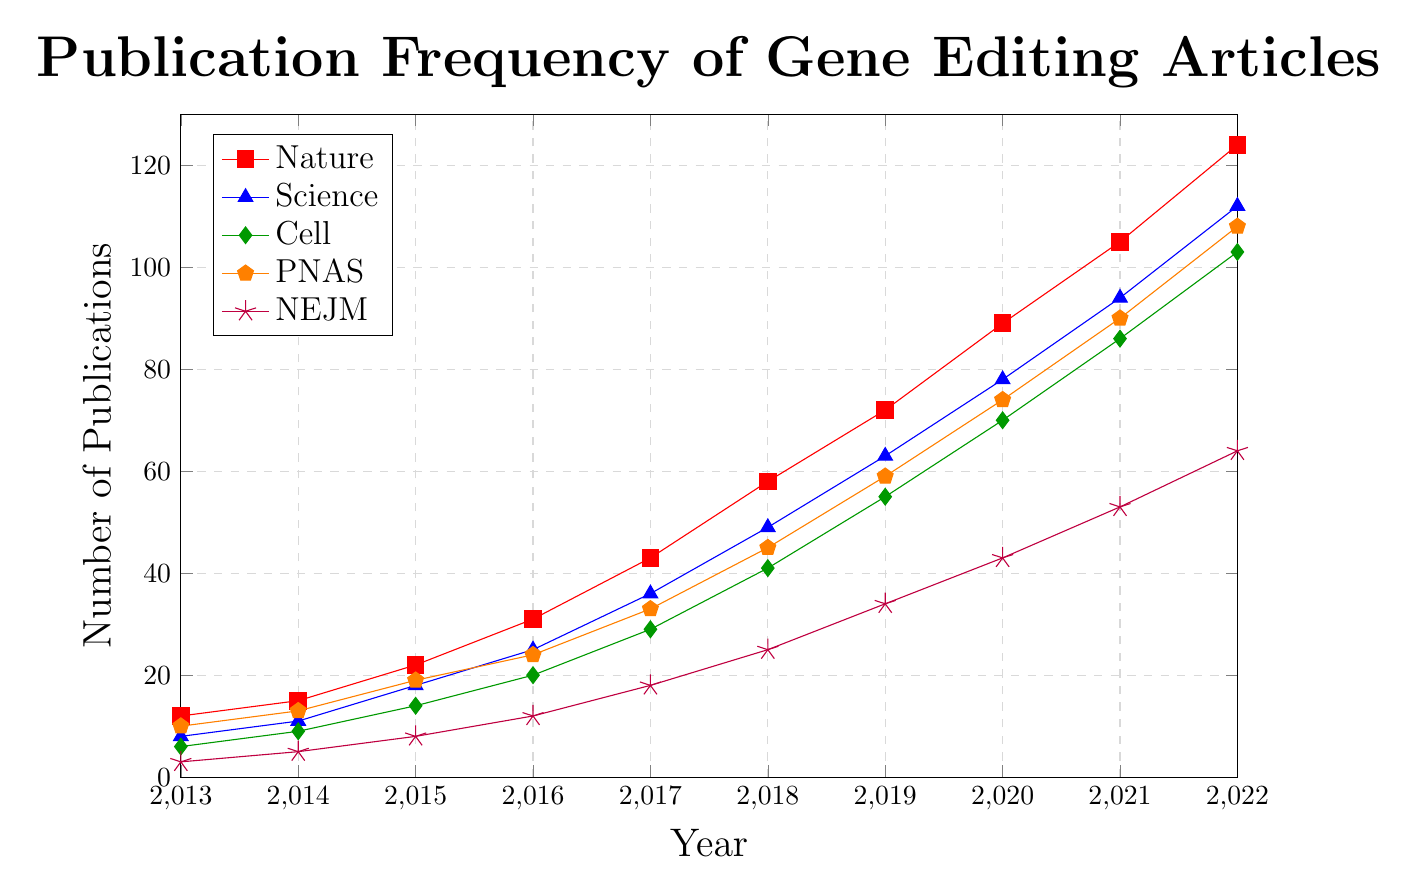Which scientific journal had the highest number of gene editing-related publications in 2022? To identify the journal with the highest number of publications in 2022, look at the end of the lines. The red line for Nature reaches 124 publications, the highest among all.
Answer: Nature What is the total number of gene editing-related publications across all journals in 2019? Sum the heights of the points for all journals in 2019: Nature (72) + Science (63) + Cell (55) + PNAS (59) + New England Journal of Medicine (34).
Answer: 283 Between 2016 and 2017, which journal saw the largest increase in the number of gene editing-related publications? Calculate the differences for each journal between 2016 and 2017: Nature (43-31=12), Science (36-25=11), Cell (29-20=9), PNAS (33-24=9), and New England Journal of Medicine (18-12=6). Nature saw the largest increase.
Answer: Nature In what year did PNAS surpass 50 gene editing-related publications? Trace the line for PNAS and find the first point where it goes above 50. This occurs in 2019, where PNAS has 59 publications.
Answer: 2019 Which journal had the smallest percentage increase in gene editing-related publications from 2014 to 2015? Calculate the percentage increase for each journal:
- Nature: (22-15)/15 * 100 = 46.67%
- Science: (18-11)/11 * 100 = 63.64%
- Cell: (14-9)/9 * 100 = 55.56%
- PNAS: (19-13)/13 * 100 = 46.15%
- New England Journal of Medicine: (8-5)/5 * 100 = 60%
PNAS has the smallest percentage increase.
Answer: PNAS How many more gene editing-related articles did Nature publish in 2022 compared to 2020? Subtract the number of publications in 2020 from those in 2022 for Nature: 124 - 89.
Answer: 35 Which journal’s publication trend line shows the steepest increase in publications from 2013 to 2022? Determine the overall slope of each journal's line from 2013 to 2022. Nature has the steepest increase, as its slope is the steepest, going from 12 to 124.
Answer: Nature By how much did the number of gene editing-related articles in the New England Journal of Medicine increase from 2013 to 2022? Subtract the 2013 value from the 2022 value for NEJM: 64 - 3.
Answer: 61 